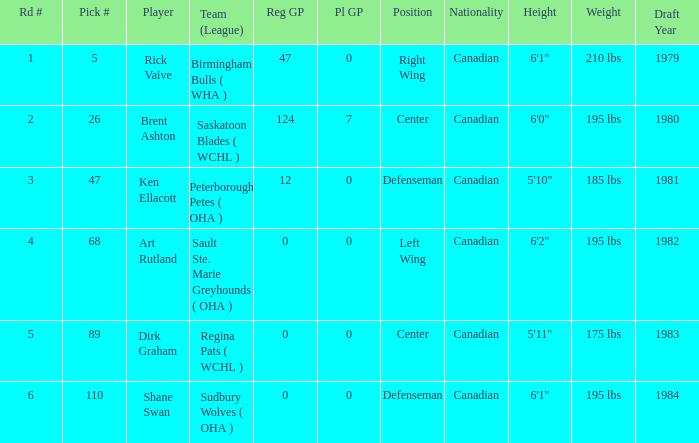How many reg GP for rick vaive in round 1? None. 